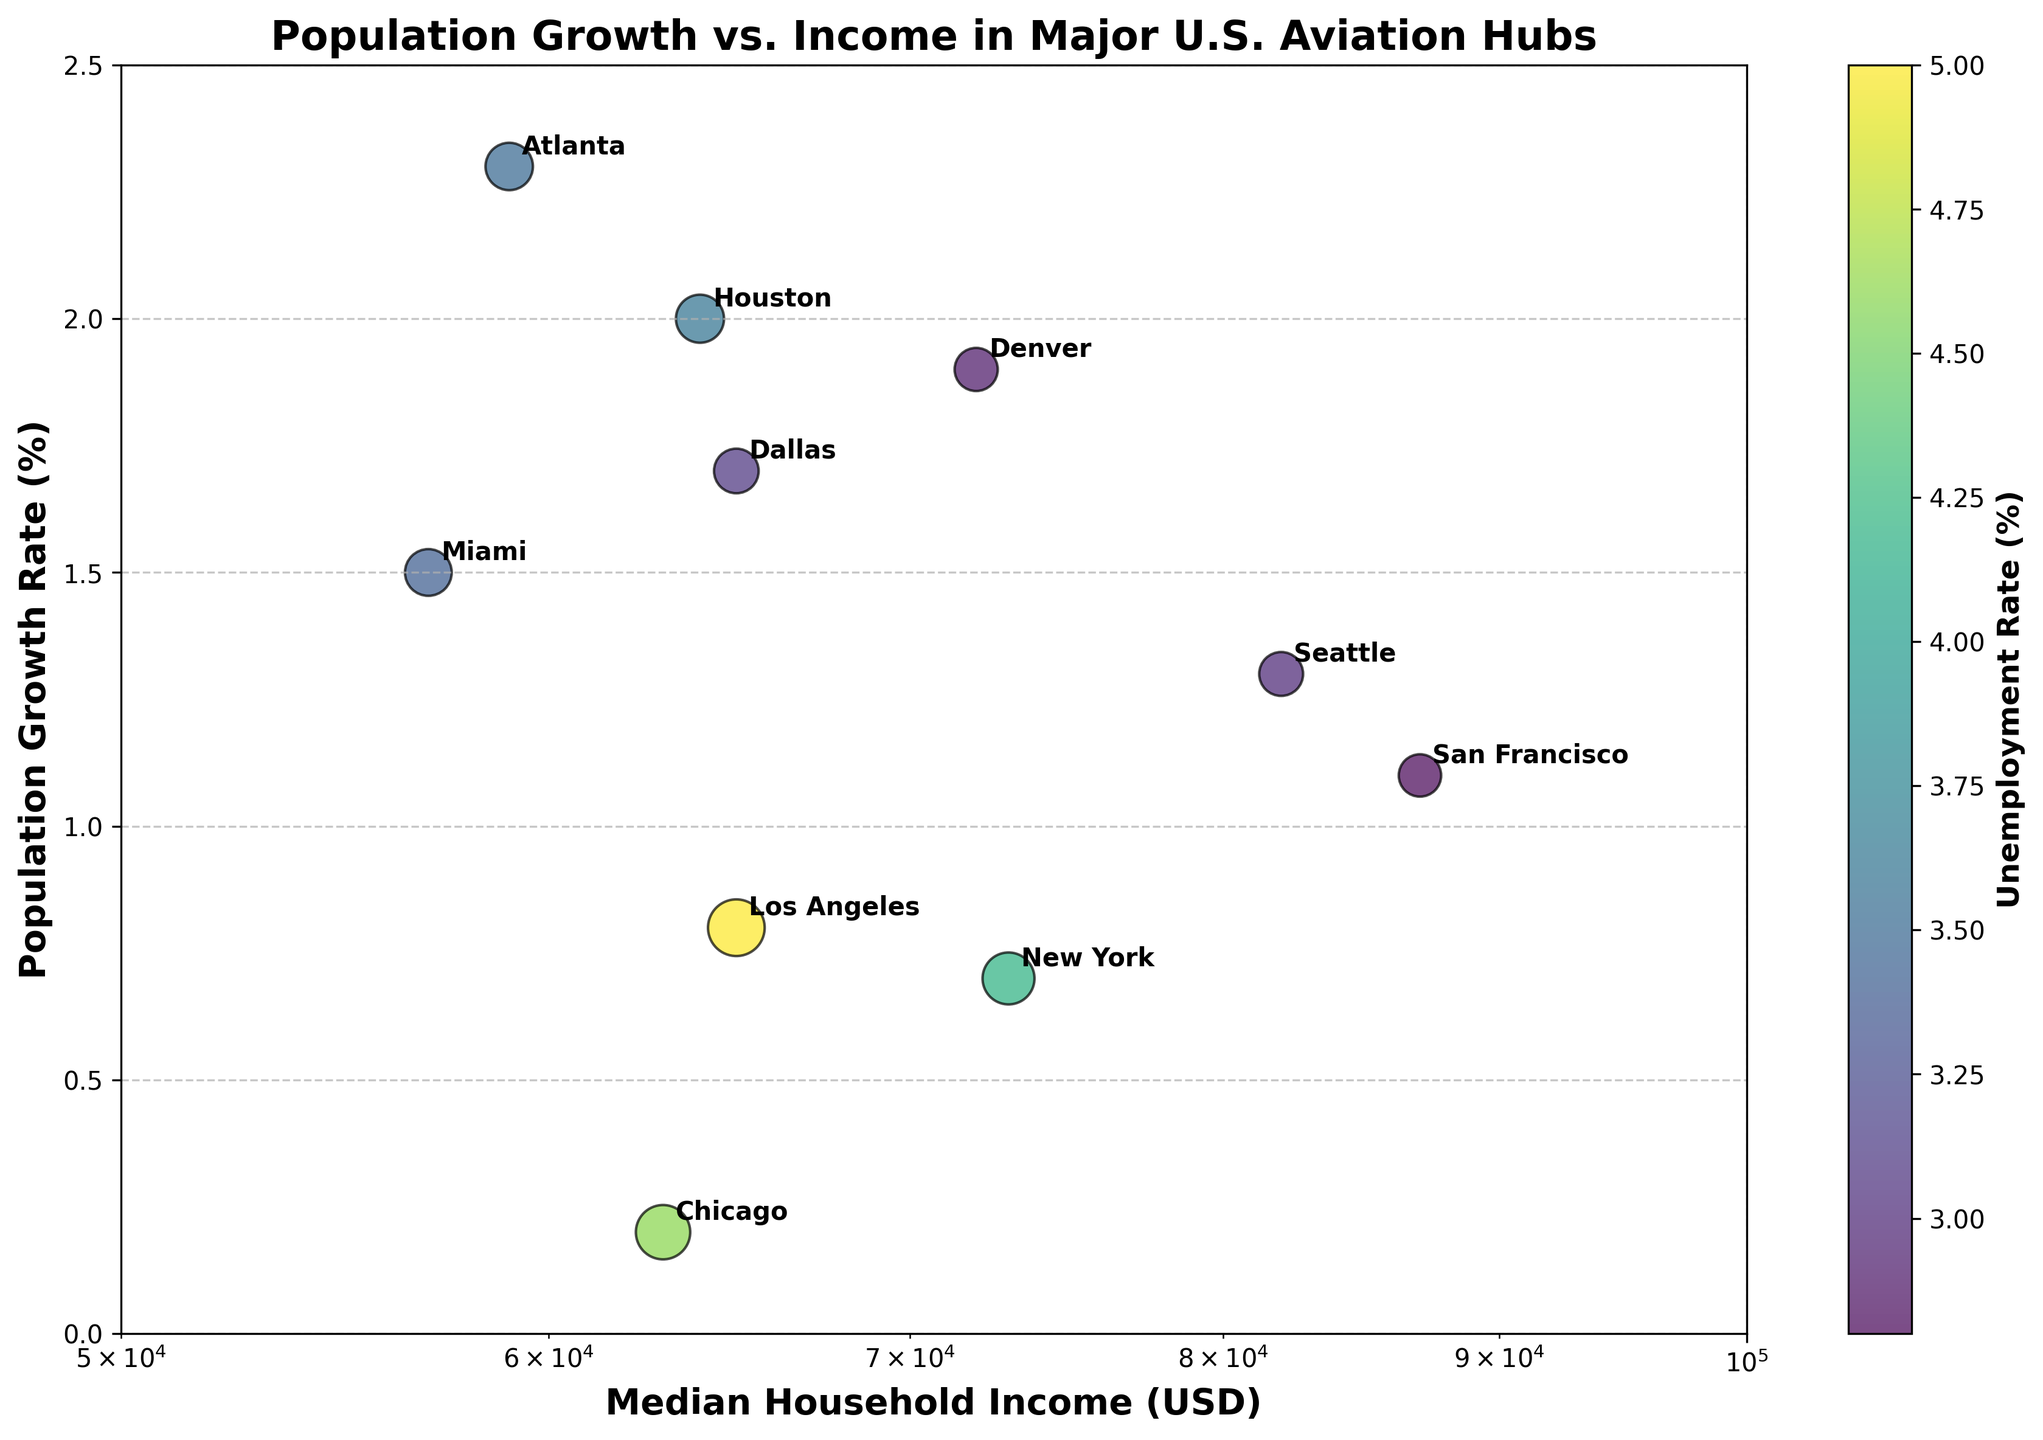what is the title of the plot? The title is usually found at the top of the plot, and it describes what the plot is showing. In this case, it should be clearly visible.
Answer: Population Growth vs. Income in Major U.S. Aviation Hubs how many cities are plotted on the scatter plot? By counting the number of data points or annotated city names, you can determine the total number of cities plotted. Each city has a corresponding dot with annotations.
Answer: 10 which city has the highest median household income? By looking at the x-axis, find the city name corresponding to the farthest right data point.
Answer: San Francisco which city has the lowest population growth rate? By examining the y-axis, find the city with its data point closest to the bottom.
Answer: Chicago how is the unemployment rate represented in the plot? The unemployment rate can be represented by color, size, or other aspects of the plot markers. Here, check the color legend and the marker sizes.
Answer: By both color and size of the data points which city has both the highest population growth rate and the lowest median household income? By cross-referencing the highest values on the y-axis and the lowest values on the x-axis, find the city that matches both criteria.
Answer: Atlanta compare the population growth rate of Dallas and Miami. Which one is higher? Locate the data points for both Dallas and Miami on the plot and compare their positions on the y-axis.
Answer: Dallas what is the range of median household incomes displayed on the log scale x-axis? Look at the x-axis labels to determine the minimum and maximum log-scale values.
Answer: 50,000 to 100,000 USD which city has the smallest unemployment rate and what is its median household income? Find the smallest marker (representing the lowest unemployment rate) and read the corresponding x-axis value for income.
Answer: Denver, 72,000 USD Do higher median household incomes tend to correlate with higher or lower population growth rates based on the scatter plot? Observe the overall trend formed by the scatter plot's data points to understand the correlation between the x-axis and y-axis.
Answer: No clear pattern 